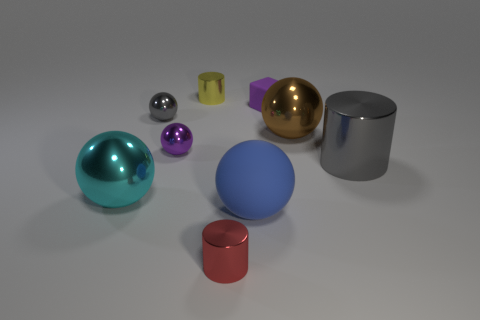Is there anything else that has the same color as the large shiny cylinder?
Offer a terse response. Yes. There is a cylinder that is both in front of the purple block and on the left side of the tiny block; what is its color?
Your answer should be compact. Red. Do the sphere that is on the right side of the blue matte ball and the big metallic cylinder have the same size?
Provide a succinct answer. Yes. Is the number of objects on the right side of the big rubber object greater than the number of big rubber balls?
Offer a very short reply. Yes. Does the small yellow object have the same shape as the large blue thing?
Your answer should be compact. No. What is the size of the red metal cylinder?
Your answer should be compact. Small. Is the number of large gray shiny cylinders behind the small purple matte thing greater than the number of small yellow cylinders that are on the right side of the small red metal thing?
Your answer should be very brief. No. Are there any tiny gray metallic things in front of the red metallic object?
Make the answer very short. No. Are there any green spheres that have the same size as the purple sphere?
Your answer should be very brief. No. There is a object that is the same material as the cube; what is its color?
Keep it short and to the point. Blue. 